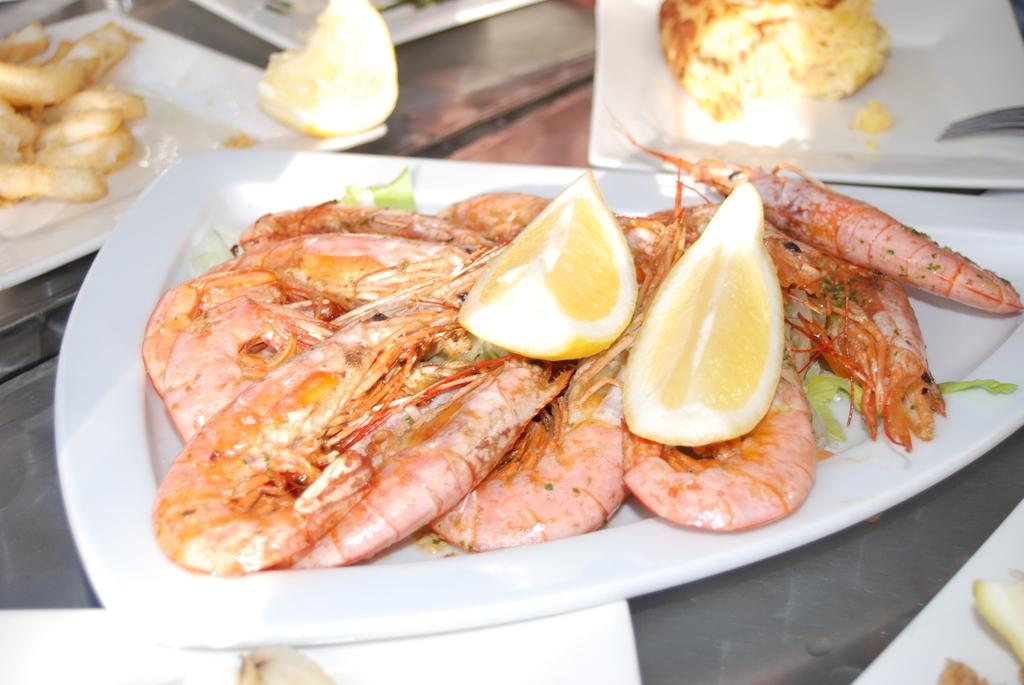What type of seafood can be seen in the image? There are prawns in the image. What fruit is also present in the image? There are lemons in the image. How are the prawns and lemons arranged in the image? The prawns and lemons are placed on a plate in the image. What color are the plates in the image? The plates in the image are white. What can be inferred about the image based on the presence of prawns and lemons? There is food visible in the image. What type of watch can be seen on the prawns in the image? There is no watch present on the prawns in the image. Are there any grapes visible in the image? There are no grapes present in the image. 